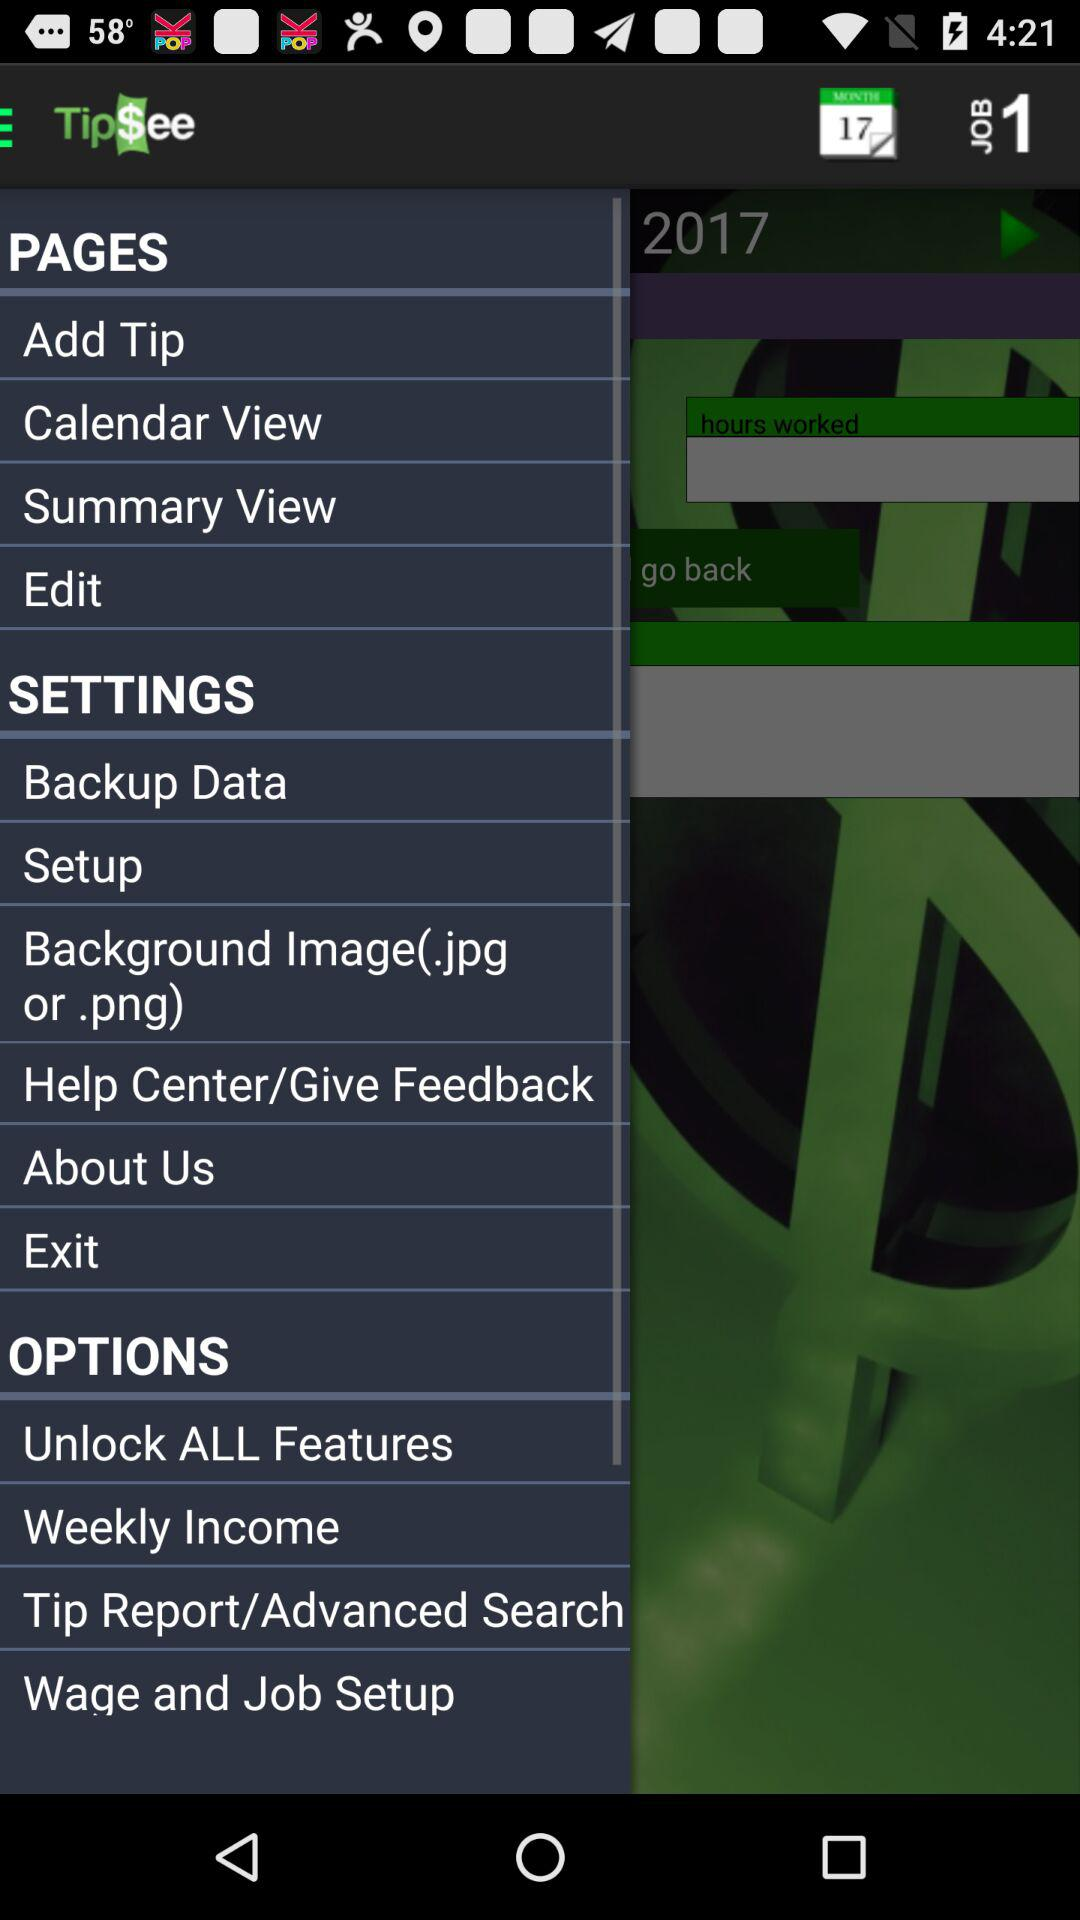What date is selected in the calendar? The selected date is February 18, 2017. 